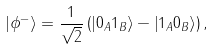Convert formula to latex. <formula><loc_0><loc_0><loc_500><loc_500>\left | \phi ^ { - } \right \rangle = \frac { 1 } { \sqrt { 2 } } \left ( \left | 0 _ { A } 1 _ { B } \right \rangle - \left | 1 _ { A } 0 _ { B } \right \rangle \right ) ,</formula> 